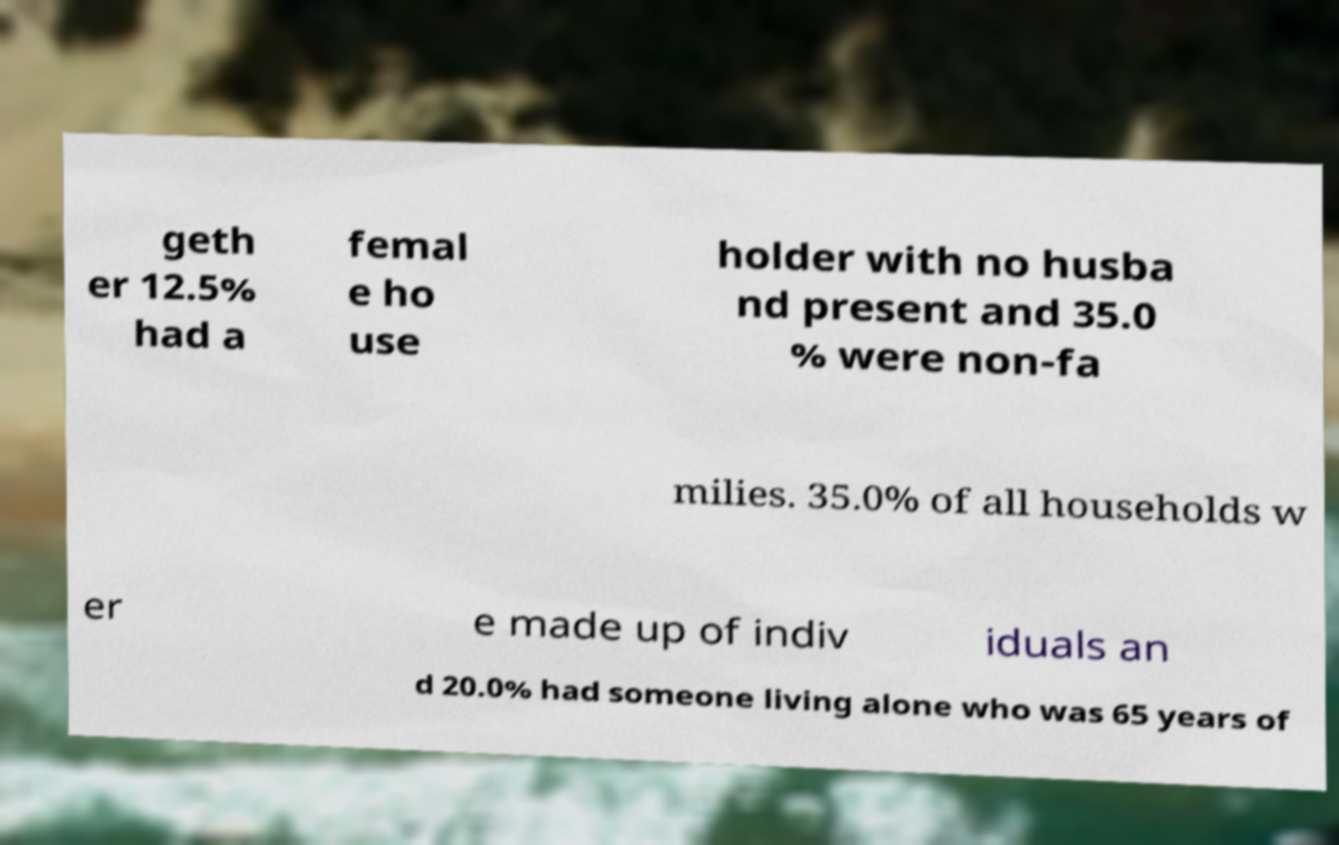What messages or text are displayed in this image? I need them in a readable, typed format. geth er 12.5% had a femal e ho use holder with no husba nd present and 35.0 % were non-fa milies. 35.0% of all households w er e made up of indiv iduals an d 20.0% had someone living alone who was 65 years of 